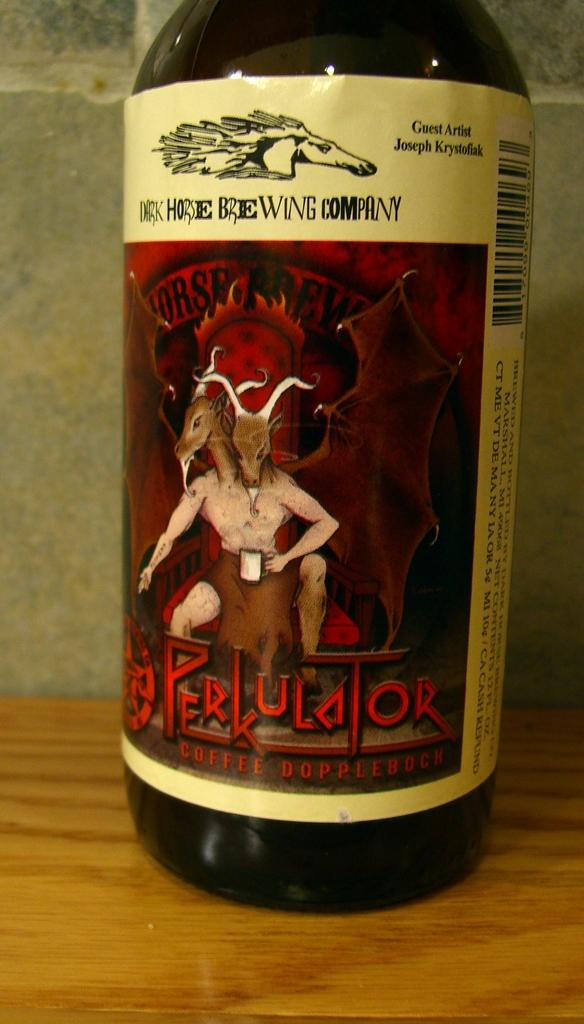<image>
Write a terse but informative summary of the picture. A bottle of beer with a goat man on it called Perkulator. 